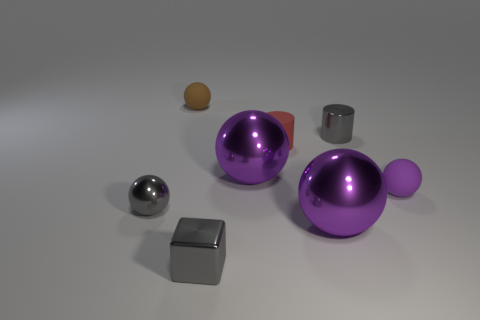Subtract all large spheres. How many spheres are left? 3 Add 2 cylinders. How many objects exist? 10 Subtract all blocks. How many objects are left? 7 Subtract all gray blocks. How many purple balls are left? 3 Subtract 1 cubes. How many cubes are left? 0 Subtract all purple spheres. Subtract all tiny purple balls. How many objects are left? 4 Add 8 cylinders. How many cylinders are left? 10 Add 6 brown matte objects. How many brown matte objects exist? 7 Subtract all red cylinders. How many cylinders are left? 1 Subtract 0 brown blocks. How many objects are left? 8 